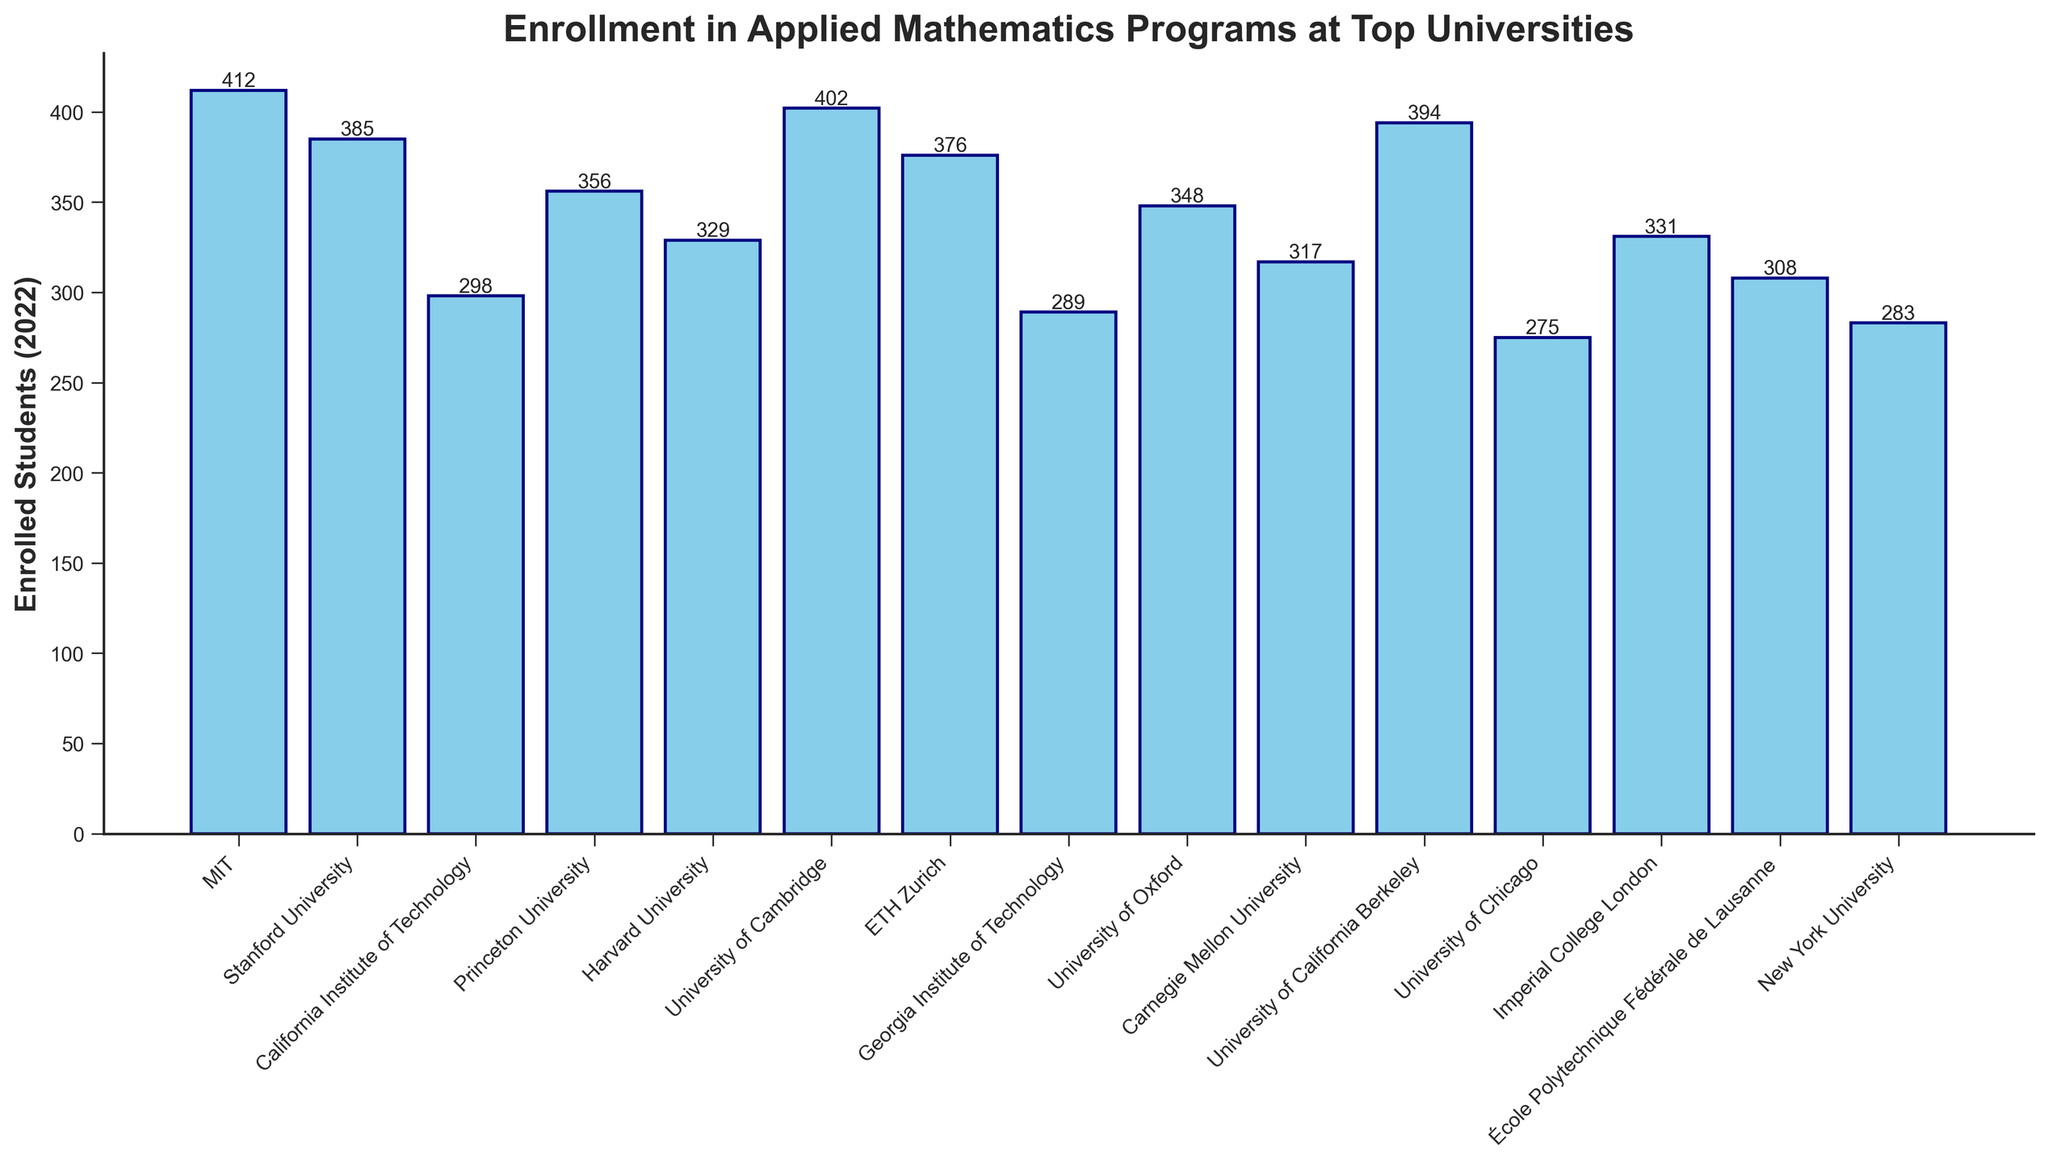Which university has the highest enrollment in applied mathematics programs for 2022? By looking at the heights of the bars, the University of Cambridge has the highest enrollment number with 402 students.
Answer: University of Cambridge Which university has the lowest enrollment in applied mathematics programs for 2022? By comparing the heights of all bars, the University of Chicago has the lowest enrollment with 275 students.
Answer: University of Chicago Is the enrollment at MIT greater than that at Stanford University? By checking the heights of the bars for both universities, MIT has 412 students, which is greater than Stanford University's 385.
Answer: Yes What is the average enrollment for the top three universities in terms of enrollment? The top three universities are MIT (412), University of Cambridge (402), and University of California Berkeley (394). The average enrollment is (412 + 402 + 394) / 3 = 1208 / 3 = 402.67.
Answer: 402.67 What is the total enrollment in applied mathematics programs for all universities combined? Sum the enrollments for all universities: 412 + 385 + 298 + 356 + 329 + 402 + 376 + 289 + 348 + 317 + 394 + 275 + 331 + 308 + 283 = 5303
Answer: 5303 Which universities have an enrollment between 300 and 350 students? By examining the bars, the universities within that range are Harvard University (329), Imperial College London (331), University of Oxford (348), Princeton University (356), and École Polytechnique Fédérale de Lausanne (308).
Answer: Harvard University, Imperial College London, University of Oxford, Princeton University, École Polytechnique Fédérale de Lausanne Are there more universities with enrollment over 350 or under 350? Count the universities with enrollment over 350: MIT, Stanford University, University of Cambridge, ETH Zurich, University of California Berkeley, University of Oxford, Princeton University (7 universities). Count those with enrollment under 350: California Institute of Technology, Harvard University, Georgia Institute of Technology, Carnegie Mellon University, University of Chicago, Imperial College London, École Polytechnique Fédérale de Lausanne, New York University (8 universities). There are more universities with enrollment under 350.
Answer: Under 350 What's the difference in enrollment between the University of Oxford and Stanford University? The University of Oxford has 348 students, and Stanford University has 385 students. The difference is 385 - 348 = 37.
Answer: 37 Which university has an enrollment that is closest to the average enrollment across all universities? First, calculate the average enrollment: 5303 / 15 = 353.53. The university with the enrollment closest to 353.53 is Princeton University with 356 students.
Answer: Princeton University How many universities have an enrollment greater than 300 students? Count the universities with enrollment greater than 300 by examining the bar heights: MIT, Stanford University, California Institute of Technology, Princeton University, Harvard University, University of Cambridge, ETH Zurich, University of Oxford, Carnegie Mellon University, Imperial College London, École Polytechnique Fédérale de Lausanne (11 universities).
Answer: 11 